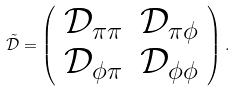<formula> <loc_0><loc_0><loc_500><loc_500>\tilde { { \mathcal { D } } } = \left ( \begin{array} { l l } { \mathcal { D } } _ { \pi \pi } & { \mathcal { D } } _ { \pi \phi } \\ { \mathcal { D } } _ { \phi \pi } & { \mathcal { D } } _ { \phi \phi } \end{array} \right ) .</formula> 